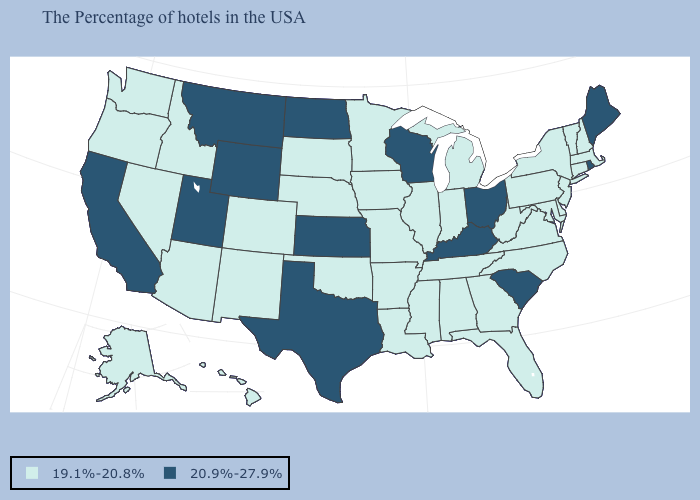Does Texas have the highest value in the South?
Short answer required. Yes. Name the states that have a value in the range 19.1%-20.8%?
Answer briefly. Massachusetts, New Hampshire, Vermont, Connecticut, New York, New Jersey, Delaware, Maryland, Pennsylvania, Virginia, North Carolina, West Virginia, Florida, Georgia, Michigan, Indiana, Alabama, Tennessee, Illinois, Mississippi, Louisiana, Missouri, Arkansas, Minnesota, Iowa, Nebraska, Oklahoma, South Dakota, Colorado, New Mexico, Arizona, Idaho, Nevada, Washington, Oregon, Alaska, Hawaii. Is the legend a continuous bar?
Answer briefly. No. What is the lowest value in the Northeast?
Keep it brief. 19.1%-20.8%. Which states have the lowest value in the USA?
Be succinct. Massachusetts, New Hampshire, Vermont, Connecticut, New York, New Jersey, Delaware, Maryland, Pennsylvania, Virginia, North Carolina, West Virginia, Florida, Georgia, Michigan, Indiana, Alabama, Tennessee, Illinois, Mississippi, Louisiana, Missouri, Arkansas, Minnesota, Iowa, Nebraska, Oklahoma, South Dakota, Colorado, New Mexico, Arizona, Idaho, Nevada, Washington, Oregon, Alaska, Hawaii. Name the states that have a value in the range 19.1%-20.8%?
Write a very short answer. Massachusetts, New Hampshire, Vermont, Connecticut, New York, New Jersey, Delaware, Maryland, Pennsylvania, Virginia, North Carolina, West Virginia, Florida, Georgia, Michigan, Indiana, Alabama, Tennessee, Illinois, Mississippi, Louisiana, Missouri, Arkansas, Minnesota, Iowa, Nebraska, Oklahoma, South Dakota, Colorado, New Mexico, Arizona, Idaho, Nevada, Washington, Oregon, Alaska, Hawaii. What is the value of Alaska?
Answer briefly. 19.1%-20.8%. Which states have the lowest value in the USA?
Write a very short answer. Massachusetts, New Hampshire, Vermont, Connecticut, New York, New Jersey, Delaware, Maryland, Pennsylvania, Virginia, North Carolina, West Virginia, Florida, Georgia, Michigan, Indiana, Alabama, Tennessee, Illinois, Mississippi, Louisiana, Missouri, Arkansas, Minnesota, Iowa, Nebraska, Oklahoma, South Dakota, Colorado, New Mexico, Arizona, Idaho, Nevada, Washington, Oregon, Alaska, Hawaii. What is the lowest value in the USA?
Write a very short answer. 19.1%-20.8%. What is the lowest value in the USA?
Keep it brief. 19.1%-20.8%. Name the states that have a value in the range 19.1%-20.8%?
Short answer required. Massachusetts, New Hampshire, Vermont, Connecticut, New York, New Jersey, Delaware, Maryland, Pennsylvania, Virginia, North Carolina, West Virginia, Florida, Georgia, Michigan, Indiana, Alabama, Tennessee, Illinois, Mississippi, Louisiana, Missouri, Arkansas, Minnesota, Iowa, Nebraska, Oklahoma, South Dakota, Colorado, New Mexico, Arizona, Idaho, Nevada, Washington, Oregon, Alaska, Hawaii. Name the states that have a value in the range 19.1%-20.8%?
Keep it brief. Massachusetts, New Hampshire, Vermont, Connecticut, New York, New Jersey, Delaware, Maryland, Pennsylvania, Virginia, North Carolina, West Virginia, Florida, Georgia, Michigan, Indiana, Alabama, Tennessee, Illinois, Mississippi, Louisiana, Missouri, Arkansas, Minnesota, Iowa, Nebraska, Oklahoma, South Dakota, Colorado, New Mexico, Arizona, Idaho, Nevada, Washington, Oregon, Alaska, Hawaii. Name the states that have a value in the range 19.1%-20.8%?
Give a very brief answer. Massachusetts, New Hampshire, Vermont, Connecticut, New York, New Jersey, Delaware, Maryland, Pennsylvania, Virginia, North Carolina, West Virginia, Florida, Georgia, Michigan, Indiana, Alabama, Tennessee, Illinois, Mississippi, Louisiana, Missouri, Arkansas, Minnesota, Iowa, Nebraska, Oklahoma, South Dakota, Colorado, New Mexico, Arizona, Idaho, Nevada, Washington, Oregon, Alaska, Hawaii. What is the lowest value in states that border Montana?
Write a very short answer. 19.1%-20.8%. 